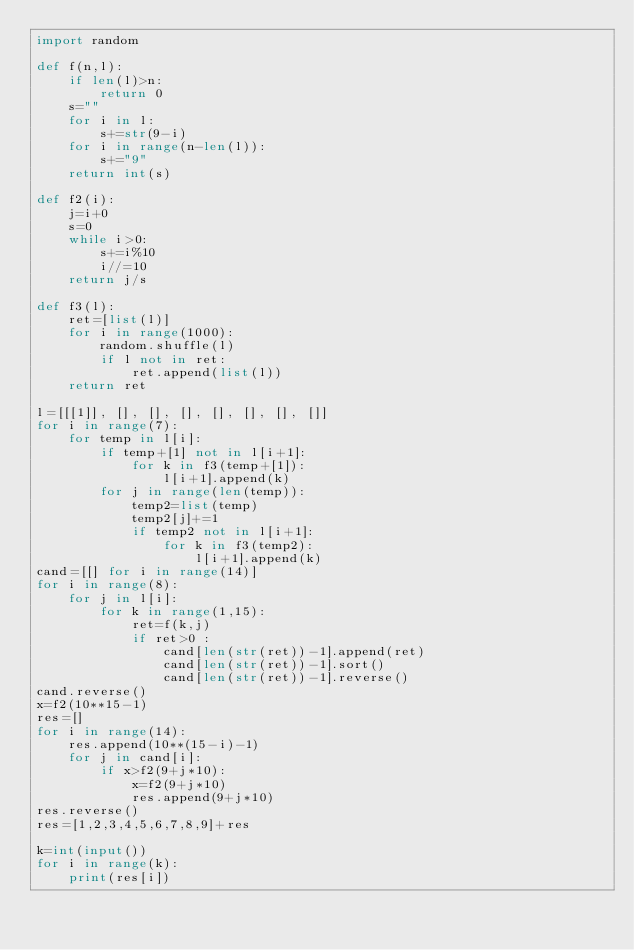Convert code to text. <code><loc_0><loc_0><loc_500><loc_500><_Python_>import random

def f(n,l):
    if len(l)>n:
        return 0
    s=""
    for i in l:
        s+=str(9-i)
    for i in range(n-len(l)):
        s+="9"
    return int(s)

def f2(i):
    j=i+0
    s=0
    while i>0:
        s+=i%10
        i//=10
    return j/s

def f3(l):
    ret=[list(l)]
    for i in range(1000):
        random.shuffle(l)
        if l not in ret:
            ret.append(list(l))
    return ret

l=[[[1]], [], [], [], [], [], [], []]
for i in range(7):
    for temp in l[i]:
        if temp+[1] not in l[i+1]:
            for k in f3(temp+[1]):
                l[i+1].append(k)
        for j in range(len(temp)):
            temp2=list(temp)
            temp2[j]+=1
            if temp2 not in l[i+1]:
                for k in f3(temp2):
                    l[i+1].append(k)
cand=[[] for i in range(14)]
for i in range(8):
    for j in l[i]:
        for k in range(1,15):
            ret=f(k,j)
            if ret>0 :
                cand[len(str(ret))-1].append(ret)
                cand[len(str(ret))-1].sort()
                cand[len(str(ret))-1].reverse()
cand.reverse()
x=f2(10**15-1)
res=[]
for i in range(14):
    res.append(10**(15-i)-1)
    for j in cand[i]:
        if x>f2(9+j*10):
            x=f2(9+j*10)
            res.append(9+j*10)
res.reverse()
res=[1,2,3,4,5,6,7,8,9]+res

k=int(input())
for i in range(k):
    print(res[i])</code> 